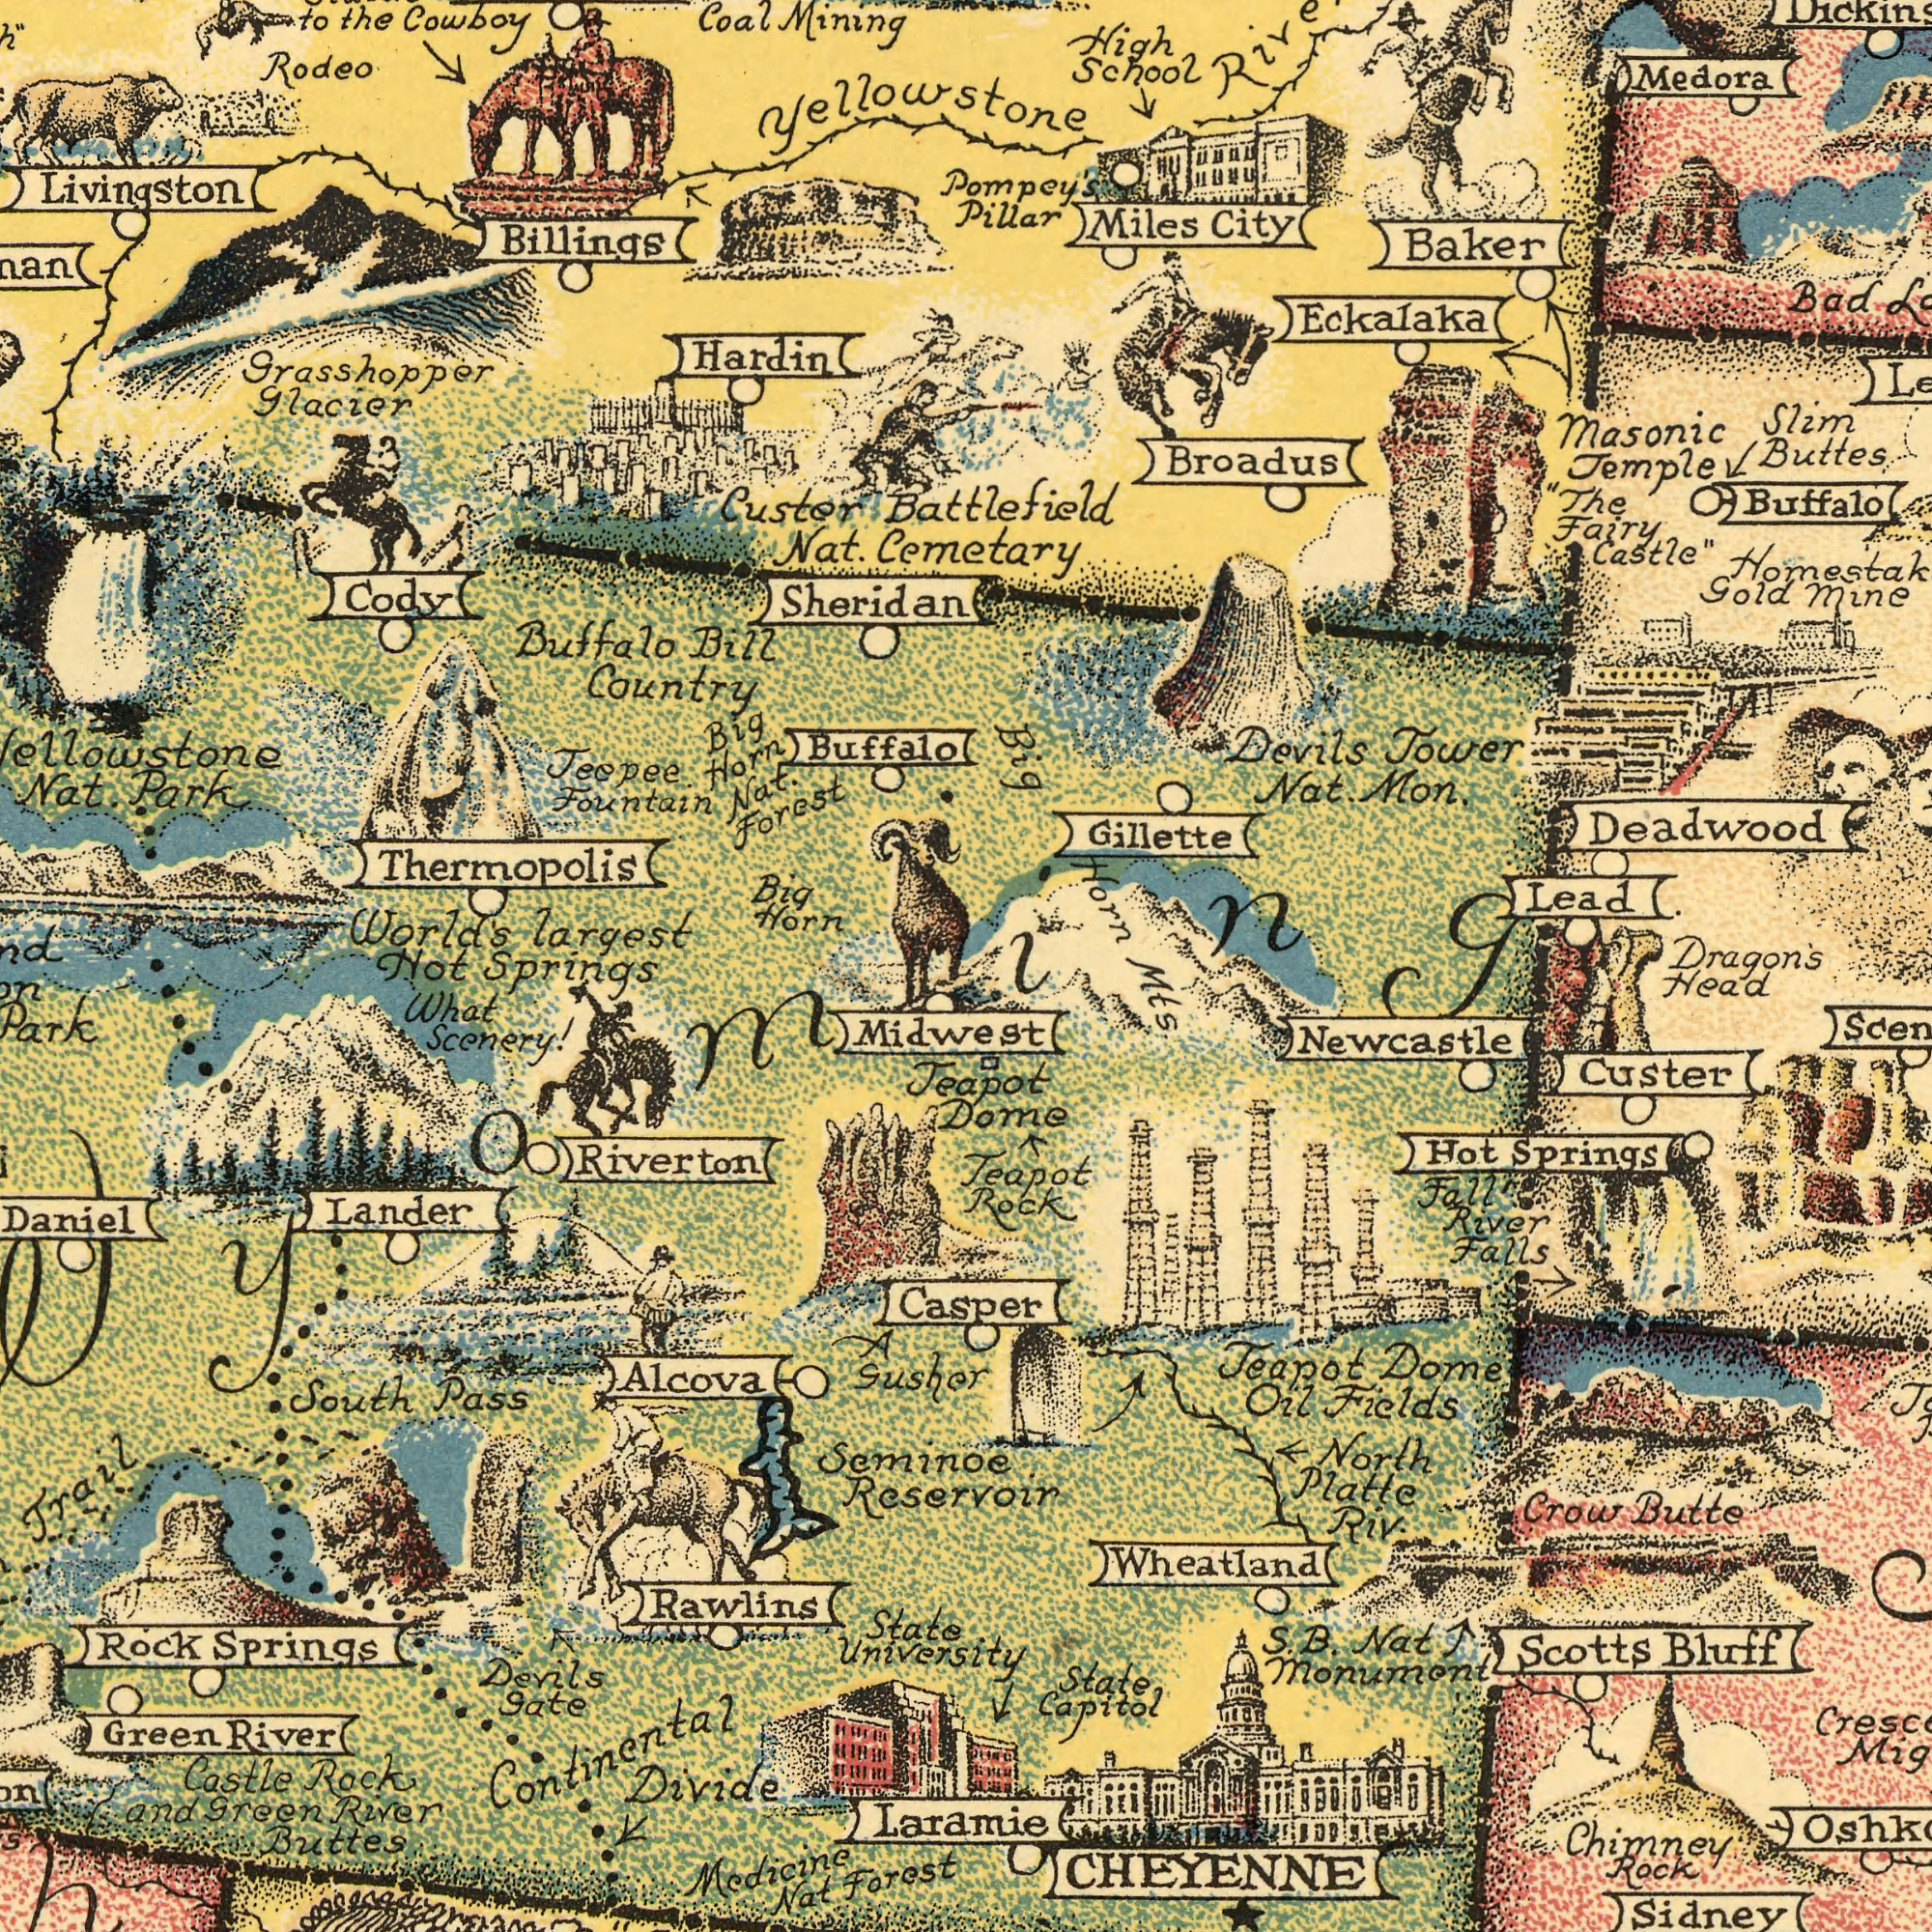What text appears in the top-right area of the image? Deadwood Miles Buttes Gillette Nat. Devils Masonic Tower Baker School Buffalo Pillar Bad Lead Medora Battlefield Castle" City Slim Mine Fairy Broadus Horn Eckalaka Gold Temple Big Mon. Pompey's High "The Cemetary Dragon's What text appears in the top-left area of the image? Livingston Fountain World's Glacier Buffalo largest Teepee. Bill Buffalo Grasshopper Hardin Billings Horn Nat. Thermopolis Big Cody Coal Custer Big Forest the Park Nat. Horn Country Nat. Sheridan Cowboy Rodeo Mining to Yellowstone Hot What text appears in the bottom-left area of the image? Scenery! Buttes Riverton Trail Daniel Pass Rawlins Divide South Alcova Springs Green River Forest State Nat Park Devils Rock Castle What Seminoe Medicine River Rock University Continental Gate and Green Lander Gusher Reservoin Midwest Springs Wyoming A What text is shown in the bottom-right quadrant? Laramie Teapot Casper Springs Custer Dome Newcastle Chimney Sidney Crow Platte North Hot Bluff CHEYENNE State Butte Teapot Nat Scotts Monument Oil Head Fall Teapot Capitol Fields River Rock Falls Dome Wheatland Riv. Rock S. Mts. B. 